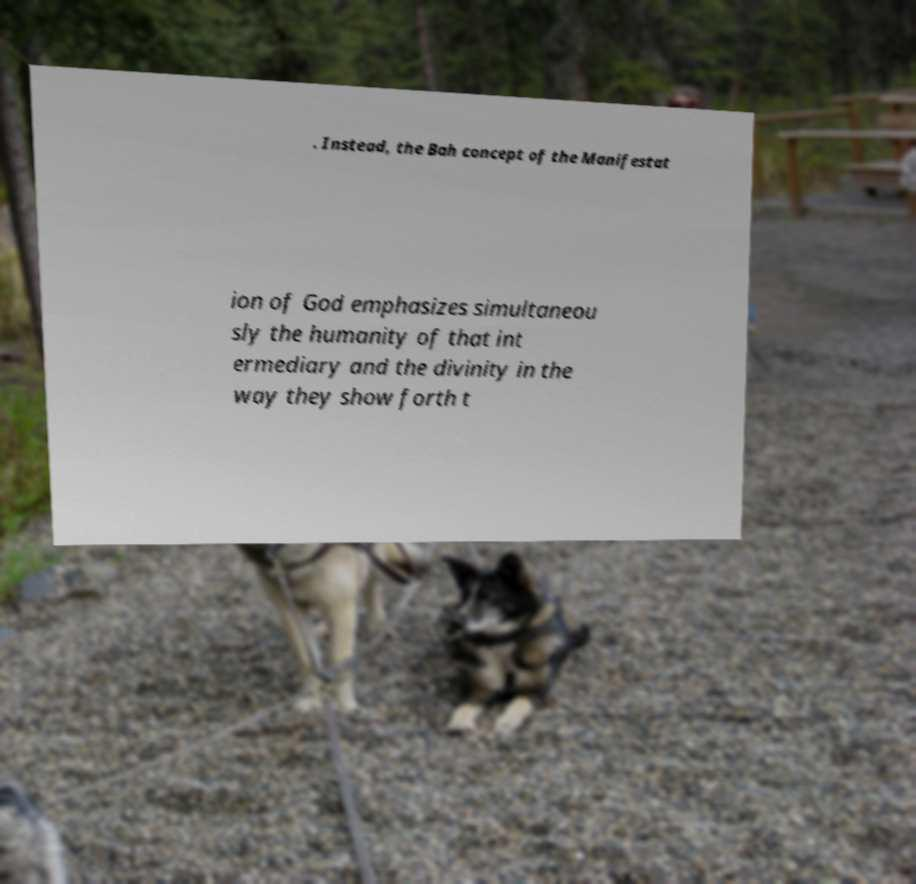There's text embedded in this image that I need extracted. Can you transcribe it verbatim? . Instead, the Bah concept of the Manifestat ion of God emphasizes simultaneou sly the humanity of that int ermediary and the divinity in the way they show forth t 